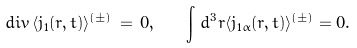Convert formula to latex. <formula><loc_0><loc_0><loc_500><loc_500>d i v \, \langle { j } _ { 1 } ( { r } , t ) \rangle ^ { ( \pm ) } \, = \, 0 , \quad \int \, d ^ { 3 } r \langle j _ { 1 \alpha } ( { r } , t ) \rangle ^ { ( \pm ) } = 0 .</formula> 